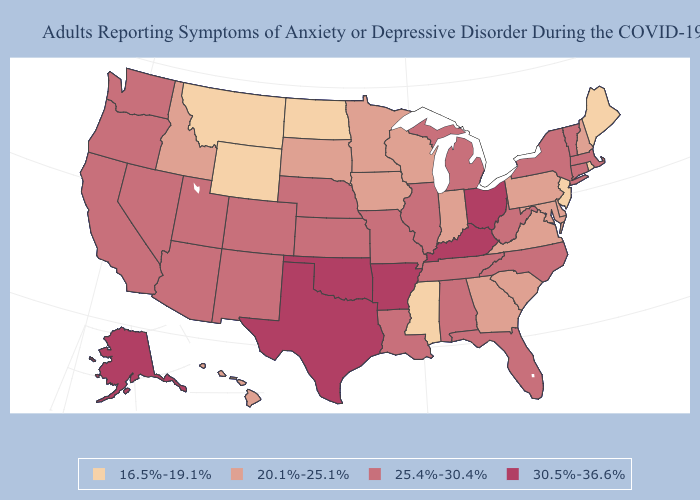Does the map have missing data?
Be succinct. No. What is the value of Minnesota?
Answer briefly. 20.1%-25.1%. Name the states that have a value in the range 20.1%-25.1%?
Quick response, please. Delaware, Georgia, Hawaii, Idaho, Indiana, Iowa, Maryland, Minnesota, New Hampshire, Pennsylvania, South Carolina, South Dakota, Virginia, Wisconsin. Which states hav the highest value in the South?
Concise answer only. Arkansas, Kentucky, Oklahoma, Texas. Which states have the highest value in the USA?
Short answer required. Alaska, Arkansas, Kentucky, Ohio, Oklahoma, Texas. How many symbols are there in the legend?
Quick response, please. 4. Among the states that border Illinois , does Iowa have the highest value?
Concise answer only. No. What is the value of Alaska?
Give a very brief answer. 30.5%-36.6%. What is the value of New Hampshire?
Concise answer only. 20.1%-25.1%. What is the lowest value in the Northeast?
Quick response, please. 16.5%-19.1%. What is the highest value in the Northeast ?
Concise answer only. 25.4%-30.4%. How many symbols are there in the legend?
Write a very short answer. 4. Which states have the lowest value in the USA?
Keep it brief. Maine, Mississippi, Montana, New Jersey, North Dakota, Rhode Island, Wyoming. Does the map have missing data?
Write a very short answer. No. Is the legend a continuous bar?
Write a very short answer. No. 